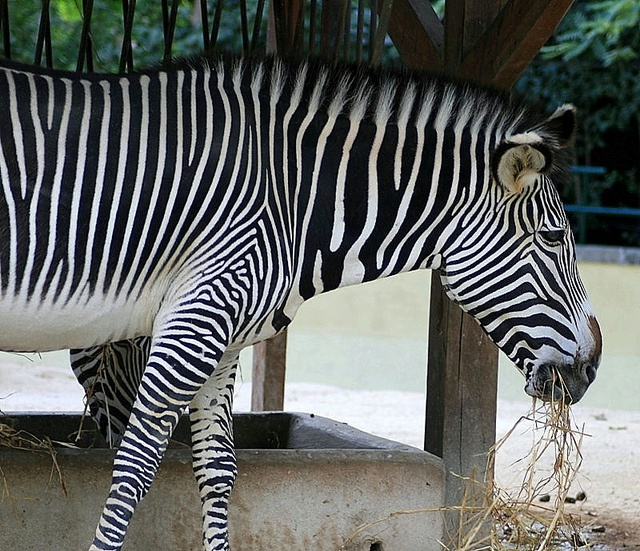Describe the objects in this image and their specific colors. I can see zebra in black, darkgray, lightgray, and gray tones and zebra in black, gray, and white tones in this image. 